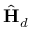<formula> <loc_0><loc_0><loc_500><loc_500>\hat { H } _ { d }</formula> 